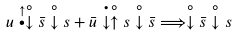<formula> <loc_0><loc_0><loc_500><loc_500>u \stackrel { \uparrow } { \bullet } \stackrel { \circ } { \downarrow } \bar { s } \stackrel { \circ } { \downarrow } s + \bar { u } \stackrel { \bullet } { \downarrow } \stackrel { \circ } { \uparrow } s \stackrel { \circ } { \downarrow } \bar { s } \Longrightarrow \stackrel { \circ } { \downarrow } \bar { s } \stackrel { \circ } { \downarrow } s</formula> 